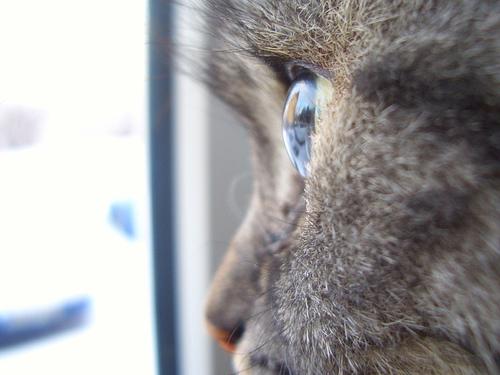What color is the cat's right eye?
Write a very short answer. Blue. Are there leaves?
Concise answer only. No. What kind of animal is this?
Short answer required. Cat. Is this a person?
Give a very brief answer. No. 